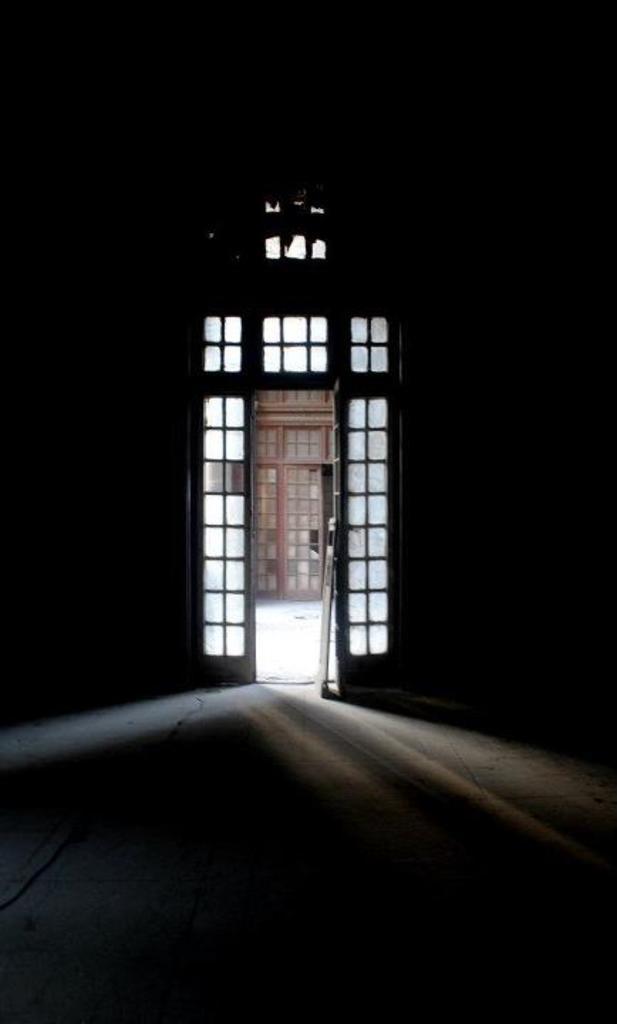Could you give a brief overview of what you see in this image? In the picture we can see a door entrance, inside it is dark and outside the entrance we can see a door which is brown in color. 